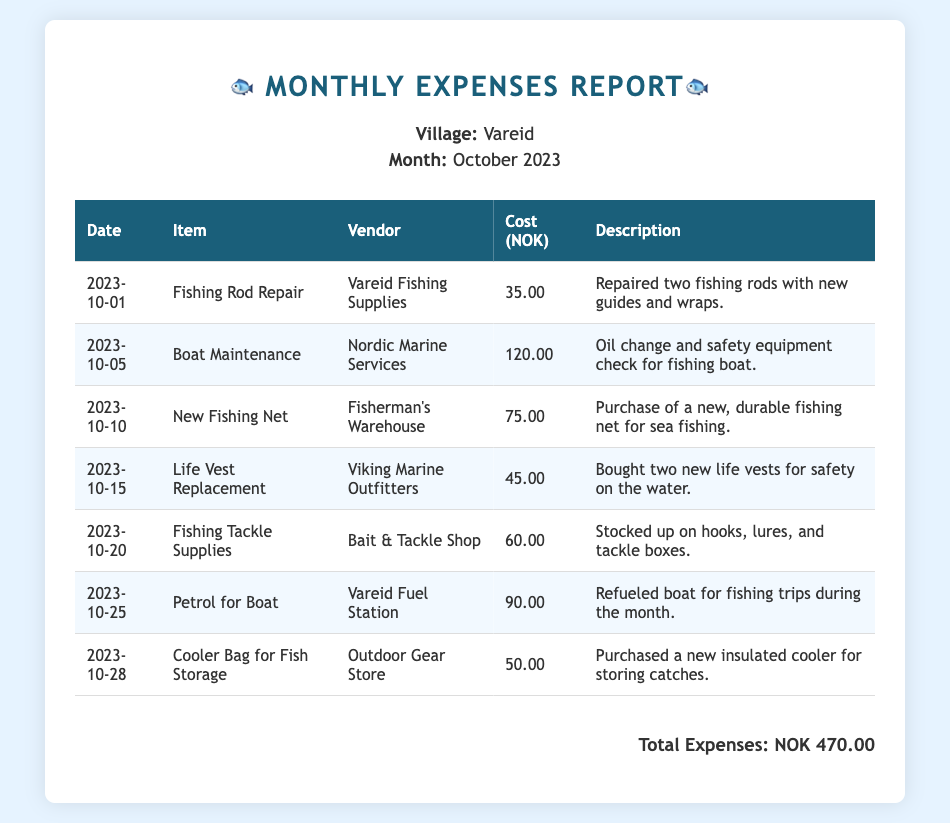What is the total expenses amount? The total expenses amount is listed at the bottom of the table as the sum of all costs incurred during the month.
Answer: NOK 470.00 Who provided the fishing rod repair service? The vendor for the fishing rod repair is identified in the transaction details under the 'Vendor' column.
Answer: Vareid Fishing Supplies What date was the new fishing net purchased? The purchase date for the new fishing net can be found in the 'Date' column corresponding to that item.
Answer: 2023-10-10 How much was spent on life vest replacements? The cost for the life vest replacement is found in the 'Cost' column next to that specific transaction.
Answer: 45.00 What item was purchased on October 20? The item purchased on that date is specified in the 'Item' column for the corresponding date.
Answer: Fishing Tackle Supplies Which vendor supplied the petrol for the boat? The vendor providing petrol for the boat can be found in the 'Vendor' column linked to that expense.
Answer: Vareid Fuel Station How many life vests were purchased? The description of the life vest replacement indicates the quantity of items bought.
Answer: Two What type of service was performed by Nordic Marine Services? The description for the service by this vendor reveals the nature of the maintenance done on the boat.
Answer: Oil change and safety equipment check Is there an item related to fish storage? By examining the items in the table, one can identify if any directly relate to storing fish.
Answer: Cooler Bag for Fish Storage 